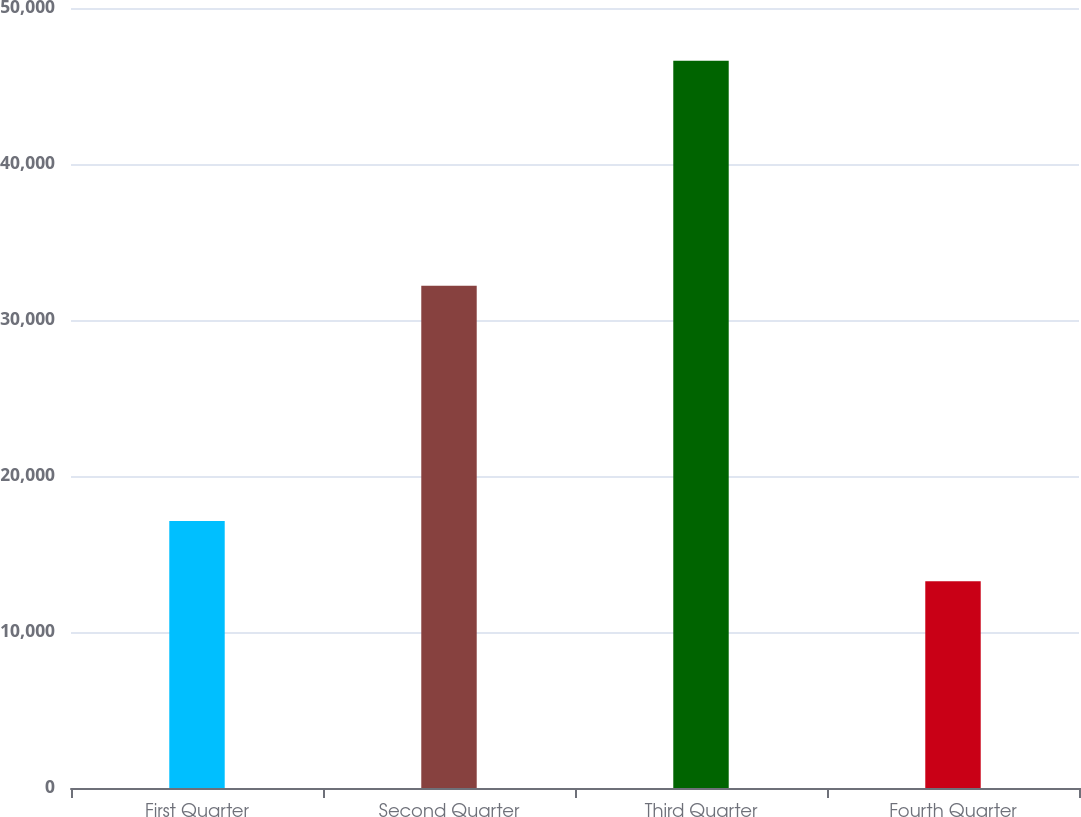<chart> <loc_0><loc_0><loc_500><loc_500><bar_chart><fcel>First Quarter<fcel>Second Quarter<fcel>Third Quarter<fcel>Fourth Quarter<nl><fcel>17118<fcel>32194<fcel>46612<fcel>13260<nl></chart> 